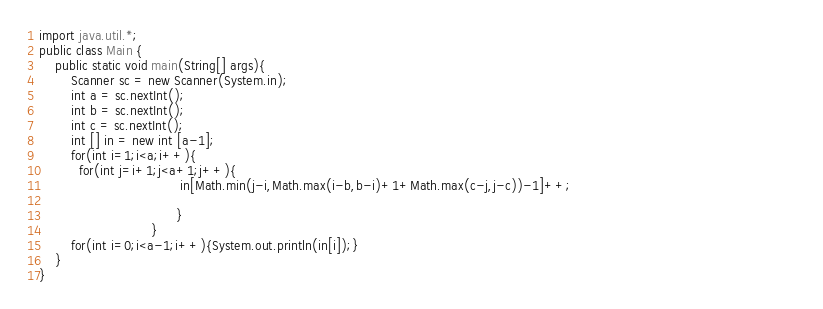<code> <loc_0><loc_0><loc_500><loc_500><_Java_>import java.util.*;
public class Main {
	public static void main(String[] args){
		Scanner sc = new Scanner(System.in);
		int a = sc.nextInt();	
        int b = sc.nextInt();
		int c = sc.nextInt();
        int [] in = new int [a-1];
        for(int i=1;i<a;i++){ 
          for(int j=i+1;j<a+1;j++){
                                   in[Math.min(j-i,Math.max(i-b,b-i)+1+Math.max(c-j,j-c))-1]++;                                                        
                                                                                                                
                                  }
                            }     
		for(int i=0;i<a-1;i++){System.out.println(in[i]);}
	}
}
</code> 